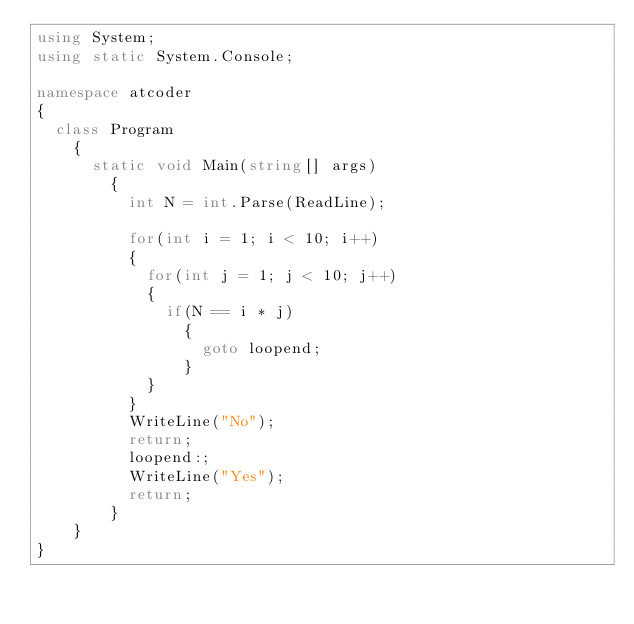<code> <loc_0><loc_0><loc_500><loc_500><_C#_>using System;
using static System.Console;

namespace atcoder
{
	class Program
    {
    	static void Main(string[] args)
        {
          int N = int.Parse(ReadLine);
          	
          for(int i = 1; i < 10; i++)
          {
          	for(int j = 1; j < 10; j++)
            {
            	if(N == i * j)
                {
                	goto loopend;
                }
            }
          }
          WriteLine("No");
          return;
          loopend:;
          WriteLine("Yes");
          return;
        }
    }
}</code> 